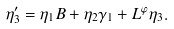<formula> <loc_0><loc_0><loc_500><loc_500>\eta ^ { \prime } _ { 3 } = \eta _ { 1 } B + \eta _ { 2 } \gamma _ { 1 } + L ^ { \varphi } \eta _ { 3 } .</formula> 